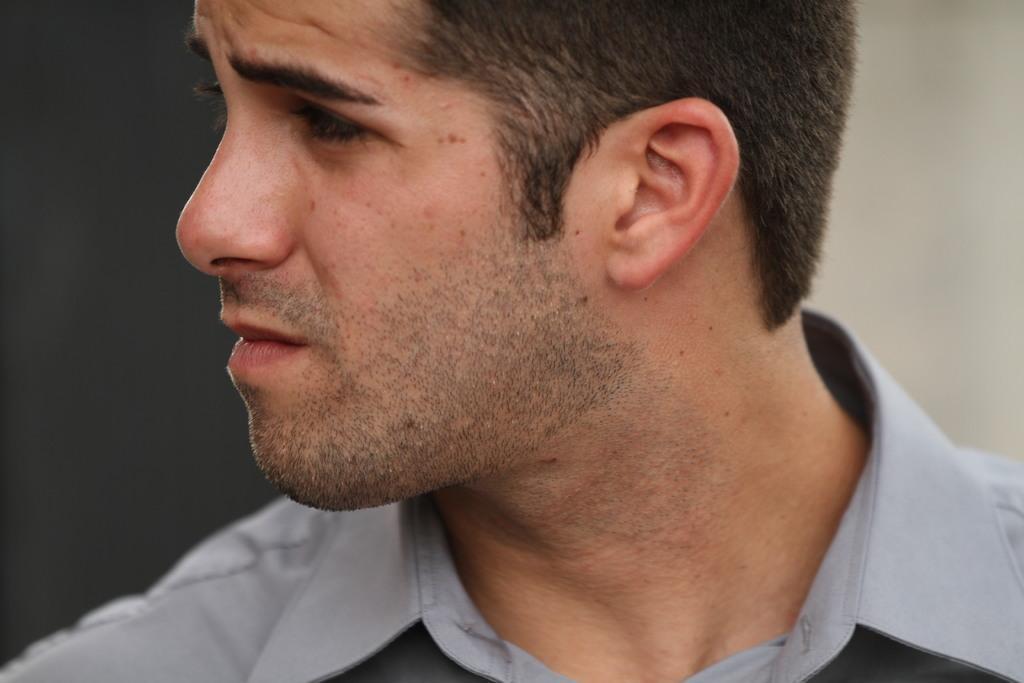In one or two sentences, can you explain what this image depicts? In this picture we can observe a person wearing grey color shirt looking on the left side. The background is blurred. 